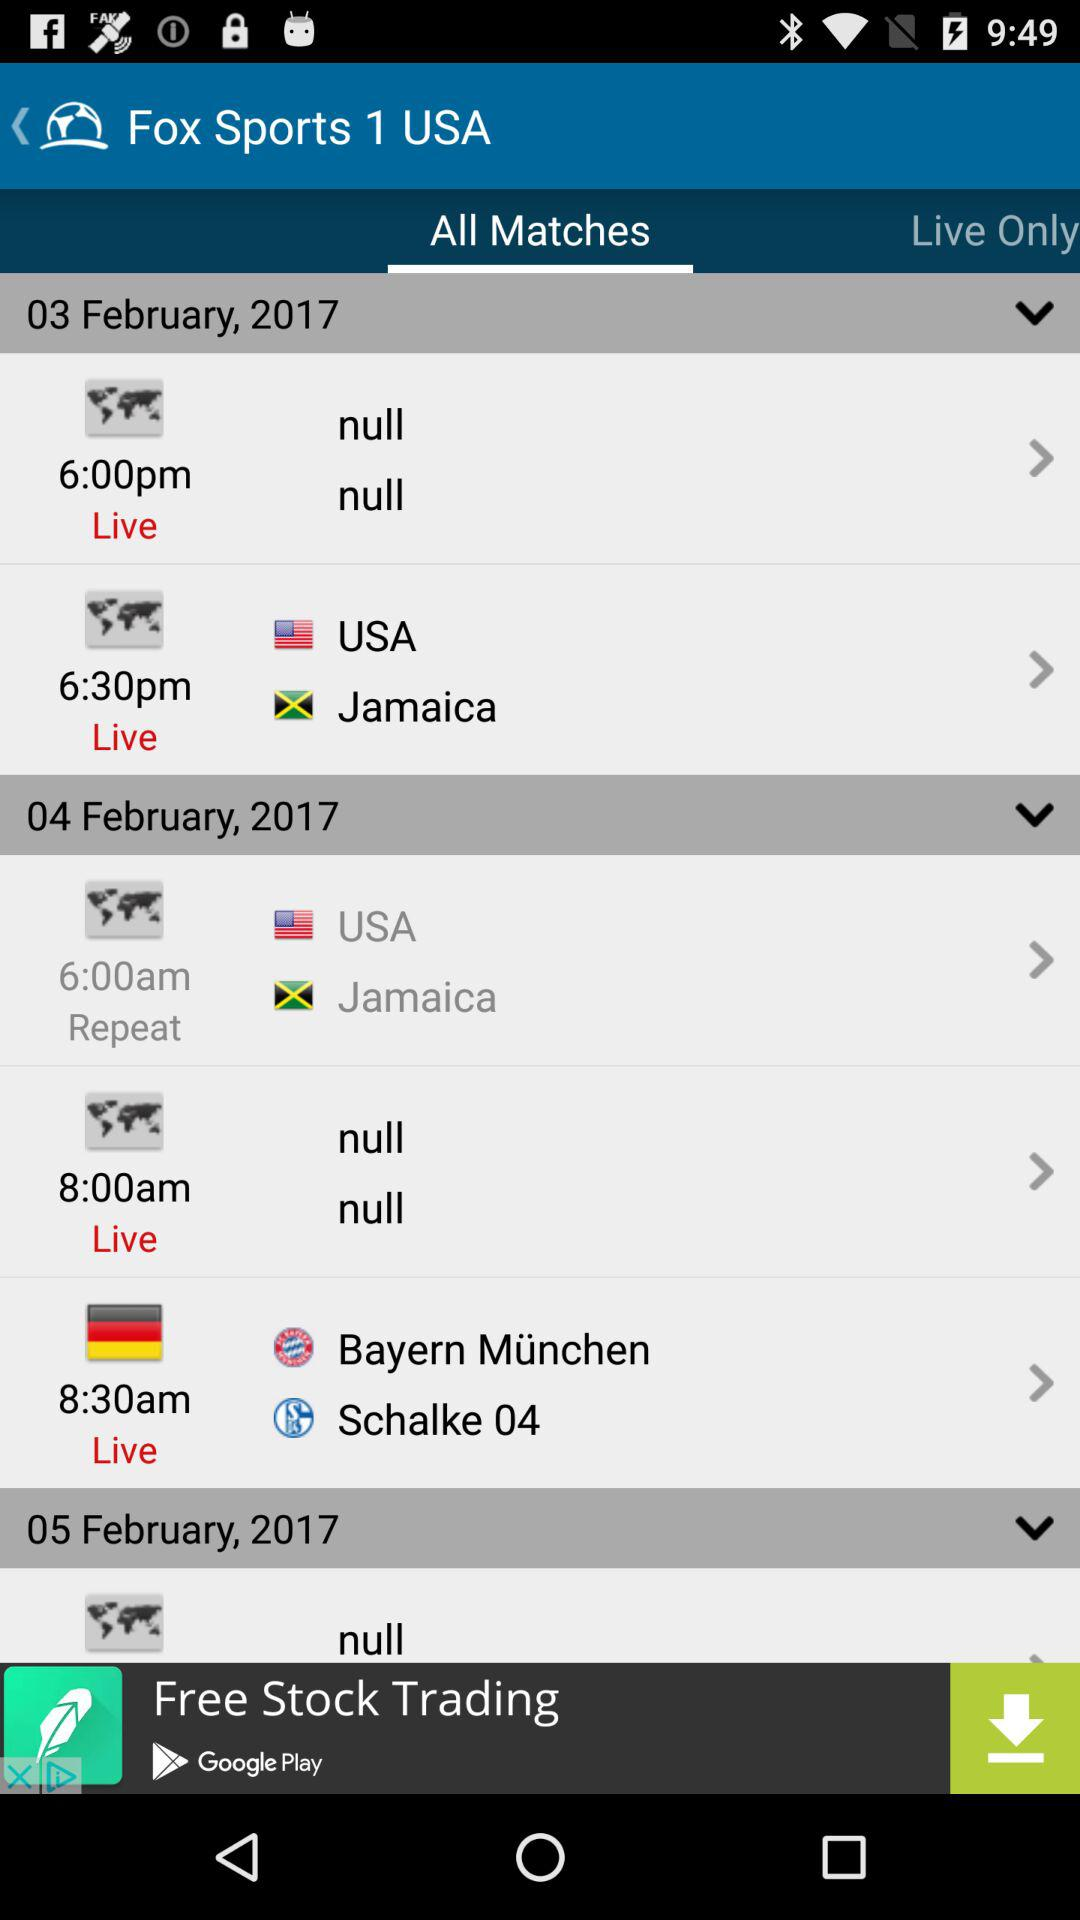On which channel will all the matches be broadcast? The channel on which all the matches will be broadcast is "Fox Sports 1 USA". 